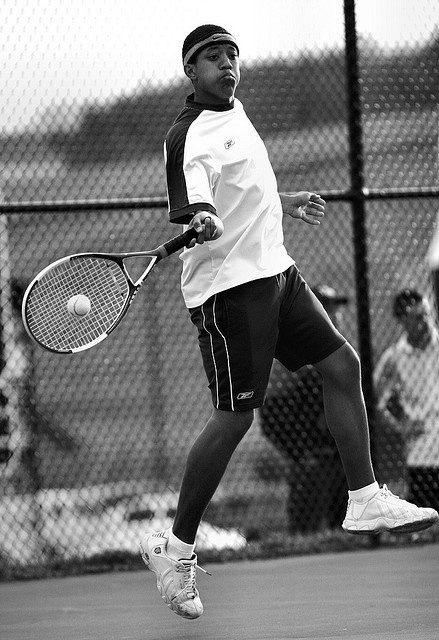Describe the objects in this image and their specific colors. I can see people in white, black, lightgray, darkgray, and gray tones, people in white, black, gray, darkgray, and lightgray tones, tennis racket in white, gray, darkgray, lightgray, and black tones, people in white, darkgray, black, gray, and lightgray tones, and people in white, darkgray, lightgray, gray, and black tones in this image. 